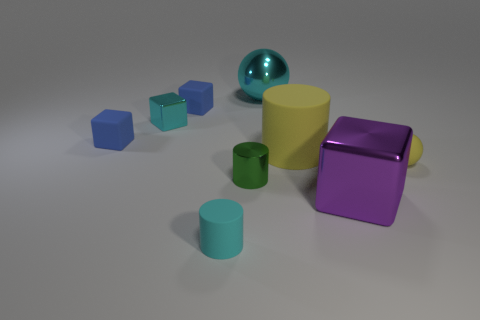Add 1 purple metal objects. How many objects exist? 10 Subtract all cylinders. How many objects are left? 6 Add 7 tiny matte spheres. How many tiny matte spheres are left? 8 Add 4 big red shiny balls. How many big red shiny balls exist? 4 Subtract 0 blue cylinders. How many objects are left? 9 Subtract all small green cylinders. Subtract all cylinders. How many objects are left? 5 